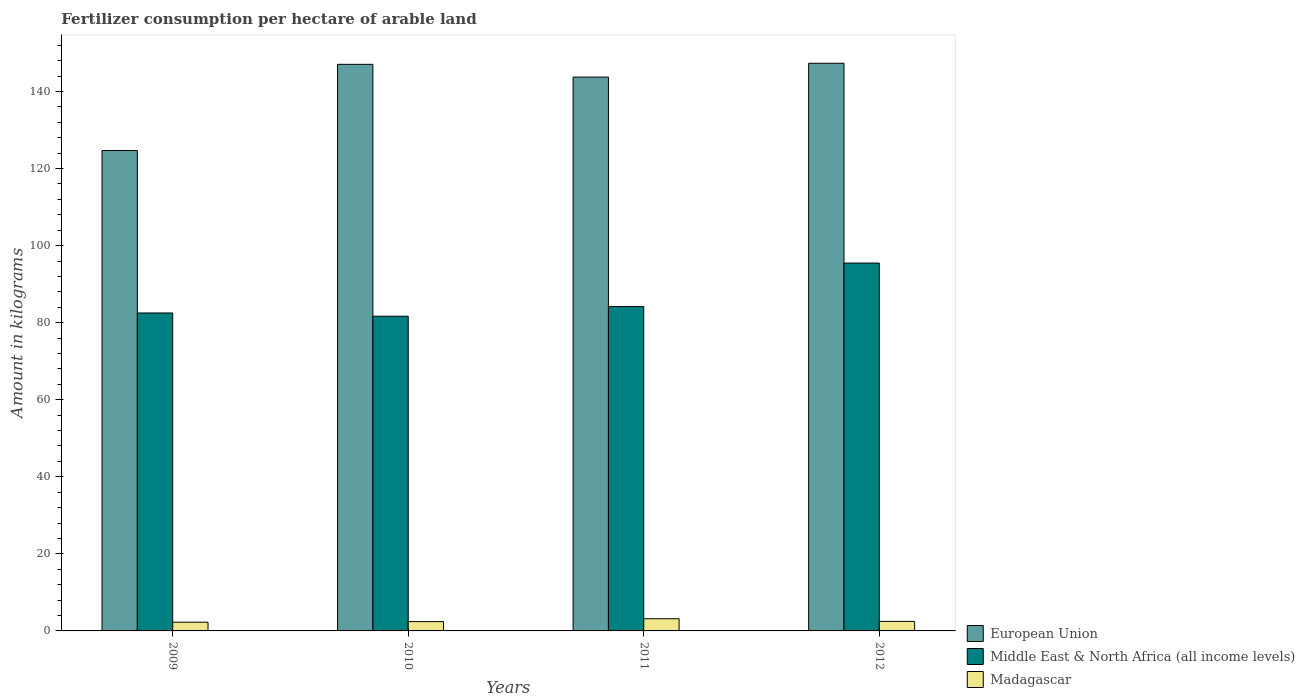Are the number of bars per tick equal to the number of legend labels?
Keep it short and to the point. Yes. Are the number of bars on each tick of the X-axis equal?
Give a very brief answer. Yes. How many bars are there on the 3rd tick from the right?
Provide a short and direct response. 3. What is the label of the 3rd group of bars from the left?
Offer a very short reply. 2011. What is the amount of fertilizer consumption in European Union in 2011?
Your answer should be compact. 143.75. Across all years, what is the maximum amount of fertilizer consumption in Middle East & North Africa (all income levels)?
Keep it short and to the point. 95.48. Across all years, what is the minimum amount of fertilizer consumption in Madagascar?
Your response must be concise. 2.27. What is the total amount of fertilizer consumption in European Union in the graph?
Make the answer very short. 562.84. What is the difference between the amount of fertilizer consumption in European Union in 2009 and that in 2011?
Provide a short and direct response. -19.07. What is the difference between the amount of fertilizer consumption in Madagascar in 2009 and the amount of fertilizer consumption in Middle East & North Africa (all income levels) in 2012?
Offer a very short reply. -93.21. What is the average amount of fertilizer consumption in Madagascar per year?
Your answer should be very brief. 2.58. In the year 2009, what is the difference between the amount of fertilizer consumption in European Union and amount of fertilizer consumption in Madagascar?
Keep it short and to the point. 122.42. What is the ratio of the amount of fertilizer consumption in Middle East & North Africa (all income levels) in 2009 to that in 2010?
Your answer should be very brief. 1.01. Is the amount of fertilizer consumption in Middle East & North Africa (all income levels) in 2009 less than that in 2011?
Provide a short and direct response. Yes. Is the difference between the amount of fertilizer consumption in European Union in 2009 and 2010 greater than the difference between the amount of fertilizer consumption in Madagascar in 2009 and 2010?
Offer a terse response. No. What is the difference between the highest and the second highest amount of fertilizer consumption in European Union?
Offer a terse response. 0.28. What is the difference between the highest and the lowest amount of fertilizer consumption in European Union?
Provide a succinct answer. 22.65. Is the sum of the amount of fertilizer consumption in European Union in 2009 and 2010 greater than the maximum amount of fertilizer consumption in Madagascar across all years?
Make the answer very short. Yes. What does the 3rd bar from the right in 2011 represents?
Keep it short and to the point. European Union. Is it the case that in every year, the sum of the amount of fertilizer consumption in Middle East & North Africa (all income levels) and amount of fertilizer consumption in Madagascar is greater than the amount of fertilizer consumption in European Union?
Offer a terse response. No. Are all the bars in the graph horizontal?
Ensure brevity in your answer.  No. How many years are there in the graph?
Provide a succinct answer. 4. Are the values on the major ticks of Y-axis written in scientific E-notation?
Keep it short and to the point. No. Does the graph contain grids?
Provide a short and direct response. No. Where does the legend appear in the graph?
Offer a very short reply. Bottom right. What is the title of the graph?
Offer a very short reply. Fertilizer consumption per hectare of arable land. Does "Bahamas" appear as one of the legend labels in the graph?
Give a very brief answer. No. What is the label or title of the Y-axis?
Your answer should be compact. Amount in kilograms. What is the Amount in kilograms of European Union in 2009?
Ensure brevity in your answer.  124.69. What is the Amount in kilograms of Middle East & North Africa (all income levels) in 2009?
Ensure brevity in your answer.  82.52. What is the Amount in kilograms of Madagascar in 2009?
Offer a very short reply. 2.27. What is the Amount in kilograms of European Union in 2010?
Your response must be concise. 147.06. What is the Amount in kilograms of Middle East & North Africa (all income levels) in 2010?
Offer a very short reply. 81.68. What is the Amount in kilograms in Madagascar in 2010?
Offer a very short reply. 2.42. What is the Amount in kilograms in European Union in 2011?
Provide a succinct answer. 143.75. What is the Amount in kilograms of Middle East & North Africa (all income levels) in 2011?
Keep it short and to the point. 84.18. What is the Amount in kilograms of Madagascar in 2011?
Keep it short and to the point. 3.16. What is the Amount in kilograms of European Union in 2012?
Your answer should be very brief. 147.34. What is the Amount in kilograms in Middle East & North Africa (all income levels) in 2012?
Provide a succinct answer. 95.48. What is the Amount in kilograms in Madagascar in 2012?
Make the answer very short. 2.48. Across all years, what is the maximum Amount in kilograms of European Union?
Offer a terse response. 147.34. Across all years, what is the maximum Amount in kilograms in Middle East & North Africa (all income levels)?
Your response must be concise. 95.48. Across all years, what is the maximum Amount in kilograms in Madagascar?
Offer a very short reply. 3.16. Across all years, what is the minimum Amount in kilograms in European Union?
Offer a terse response. 124.69. Across all years, what is the minimum Amount in kilograms of Middle East & North Africa (all income levels)?
Provide a short and direct response. 81.68. Across all years, what is the minimum Amount in kilograms of Madagascar?
Your answer should be very brief. 2.27. What is the total Amount in kilograms of European Union in the graph?
Make the answer very short. 562.84. What is the total Amount in kilograms in Middle East & North Africa (all income levels) in the graph?
Your answer should be very brief. 343.86. What is the total Amount in kilograms of Madagascar in the graph?
Ensure brevity in your answer.  10.32. What is the difference between the Amount in kilograms in European Union in 2009 and that in 2010?
Offer a very short reply. -22.37. What is the difference between the Amount in kilograms in Middle East & North Africa (all income levels) in 2009 and that in 2010?
Ensure brevity in your answer.  0.85. What is the difference between the Amount in kilograms of Madagascar in 2009 and that in 2010?
Keep it short and to the point. -0.15. What is the difference between the Amount in kilograms in European Union in 2009 and that in 2011?
Your response must be concise. -19.07. What is the difference between the Amount in kilograms of Middle East & North Africa (all income levels) in 2009 and that in 2011?
Provide a short and direct response. -1.66. What is the difference between the Amount in kilograms in Madagascar in 2009 and that in 2011?
Your answer should be very brief. -0.89. What is the difference between the Amount in kilograms in European Union in 2009 and that in 2012?
Give a very brief answer. -22.65. What is the difference between the Amount in kilograms in Middle East & North Africa (all income levels) in 2009 and that in 2012?
Offer a very short reply. -12.96. What is the difference between the Amount in kilograms of Madagascar in 2009 and that in 2012?
Provide a succinct answer. -0.21. What is the difference between the Amount in kilograms of European Union in 2010 and that in 2011?
Give a very brief answer. 3.31. What is the difference between the Amount in kilograms in Middle East & North Africa (all income levels) in 2010 and that in 2011?
Make the answer very short. -2.5. What is the difference between the Amount in kilograms in Madagascar in 2010 and that in 2011?
Your answer should be compact. -0.74. What is the difference between the Amount in kilograms in European Union in 2010 and that in 2012?
Your answer should be very brief. -0.28. What is the difference between the Amount in kilograms of Middle East & North Africa (all income levels) in 2010 and that in 2012?
Offer a very short reply. -13.8. What is the difference between the Amount in kilograms in Madagascar in 2010 and that in 2012?
Your response must be concise. -0.06. What is the difference between the Amount in kilograms of European Union in 2011 and that in 2012?
Your answer should be compact. -3.59. What is the difference between the Amount in kilograms of Middle East & North Africa (all income levels) in 2011 and that in 2012?
Ensure brevity in your answer.  -11.3. What is the difference between the Amount in kilograms of Madagascar in 2011 and that in 2012?
Your answer should be very brief. 0.68. What is the difference between the Amount in kilograms in European Union in 2009 and the Amount in kilograms in Middle East & North Africa (all income levels) in 2010?
Offer a very short reply. 43.01. What is the difference between the Amount in kilograms of European Union in 2009 and the Amount in kilograms of Madagascar in 2010?
Your response must be concise. 122.27. What is the difference between the Amount in kilograms of Middle East & North Africa (all income levels) in 2009 and the Amount in kilograms of Madagascar in 2010?
Provide a succinct answer. 80.11. What is the difference between the Amount in kilograms of European Union in 2009 and the Amount in kilograms of Middle East & North Africa (all income levels) in 2011?
Provide a short and direct response. 40.5. What is the difference between the Amount in kilograms of European Union in 2009 and the Amount in kilograms of Madagascar in 2011?
Keep it short and to the point. 121.53. What is the difference between the Amount in kilograms of Middle East & North Africa (all income levels) in 2009 and the Amount in kilograms of Madagascar in 2011?
Your answer should be compact. 79.36. What is the difference between the Amount in kilograms of European Union in 2009 and the Amount in kilograms of Middle East & North Africa (all income levels) in 2012?
Offer a very short reply. 29.21. What is the difference between the Amount in kilograms of European Union in 2009 and the Amount in kilograms of Madagascar in 2012?
Your answer should be very brief. 122.21. What is the difference between the Amount in kilograms in Middle East & North Africa (all income levels) in 2009 and the Amount in kilograms in Madagascar in 2012?
Keep it short and to the point. 80.05. What is the difference between the Amount in kilograms in European Union in 2010 and the Amount in kilograms in Middle East & North Africa (all income levels) in 2011?
Offer a terse response. 62.88. What is the difference between the Amount in kilograms in European Union in 2010 and the Amount in kilograms in Madagascar in 2011?
Provide a succinct answer. 143.9. What is the difference between the Amount in kilograms in Middle East & North Africa (all income levels) in 2010 and the Amount in kilograms in Madagascar in 2011?
Ensure brevity in your answer.  78.52. What is the difference between the Amount in kilograms of European Union in 2010 and the Amount in kilograms of Middle East & North Africa (all income levels) in 2012?
Give a very brief answer. 51.58. What is the difference between the Amount in kilograms of European Union in 2010 and the Amount in kilograms of Madagascar in 2012?
Your answer should be very brief. 144.58. What is the difference between the Amount in kilograms in Middle East & North Africa (all income levels) in 2010 and the Amount in kilograms in Madagascar in 2012?
Your answer should be very brief. 79.2. What is the difference between the Amount in kilograms of European Union in 2011 and the Amount in kilograms of Middle East & North Africa (all income levels) in 2012?
Your response must be concise. 48.27. What is the difference between the Amount in kilograms in European Union in 2011 and the Amount in kilograms in Madagascar in 2012?
Provide a succinct answer. 141.28. What is the difference between the Amount in kilograms of Middle East & North Africa (all income levels) in 2011 and the Amount in kilograms of Madagascar in 2012?
Give a very brief answer. 81.71. What is the average Amount in kilograms in European Union per year?
Provide a succinct answer. 140.71. What is the average Amount in kilograms in Middle East & North Africa (all income levels) per year?
Provide a short and direct response. 85.97. What is the average Amount in kilograms of Madagascar per year?
Your response must be concise. 2.58. In the year 2009, what is the difference between the Amount in kilograms of European Union and Amount in kilograms of Middle East & North Africa (all income levels)?
Your answer should be compact. 42.16. In the year 2009, what is the difference between the Amount in kilograms of European Union and Amount in kilograms of Madagascar?
Your response must be concise. 122.42. In the year 2009, what is the difference between the Amount in kilograms of Middle East & North Africa (all income levels) and Amount in kilograms of Madagascar?
Offer a terse response. 80.26. In the year 2010, what is the difference between the Amount in kilograms in European Union and Amount in kilograms in Middle East & North Africa (all income levels)?
Your response must be concise. 65.38. In the year 2010, what is the difference between the Amount in kilograms of European Union and Amount in kilograms of Madagascar?
Your answer should be very brief. 144.64. In the year 2010, what is the difference between the Amount in kilograms in Middle East & North Africa (all income levels) and Amount in kilograms in Madagascar?
Make the answer very short. 79.26. In the year 2011, what is the difference between the Amount in kilograms in European Union and Amount in kilograms in Middle East & North Africa (all income levels)?
Keep it short and to the point. 59.57. In the year 2011, what is the difference between the Amount in kilograms in European Union and Amount in kilograms in Madagascar?
Your answer should be very brief. 140.59. In the year 2011, what is the difference between the Amount in kilograms in Middle East & North Africa (all income levels) and Amount in kilograms in Madagascar?
Your answer should be compact. 81.02. In the year 2012, what is the difference between the Amount in kilograms of European Union and Amount in kilograms of Middle East & North Africa (all income levels)?
Your response must be concise. 51.86. In the year 2012, what is the difference between the Amount in kilograms of European Union and Amount in kilograms of Madagascar?
Keep it short and to the point. 144.86. In the year 2012, what is the difference between the Amount in kilograms in Middle East & North Africa (all income levels) and Amount in kilograms in Madagascar?
Make the answer very short. 93. What is the ratio of the Amount in kilograms in European Union in 2009 to that in 2010?
Your response must be concise. 0.85. What is the ratio of the Amount in kilograms of Middle East & North Africa (all income levels) in 2009 to that in 2010?
Your answer should be very brief. 1.01. What is the ratio of the Amount in kilograms in Madagascar in 2009 to that in 2010?
Your answer should be compact. 0.94. What is the ratio of the Amount in kilograms of European Union in 2009 to that in 2011?
Offer a terse response. 0.87. What is the ratio of the Amount in kilograms in Middle East & North Africa (all income levels) in 2009 to that in 2011?
Make the answer very short. 0.98. What is the ratio of the Amount in kilograms in Madagascar in 2009 to that in 2011?
Make the answer very short. 0.72. What is the ratio of the Amount in kilograms of European Union in 2009 to that in 2012?
Your answer should be very brief. 0.85. What is the ratio of the Amount in kilograms of Middle East & North Africa (all income levels) in 2009 to that in 2012?
Your answer should be compact. 0.86. What is the ratio of the Amount in kilograms in Madagascar in 2009 to that in 2012?
Give a very brief answer. 0.92. What is the ratio of the Amount in kilograms of European Union in 2010 to that in 2011?
Keep it short and to the point. 1.02. What is the ratio of the Amount in kilograms in Middle East & North Africa (all income levels) in 2010 to that in 2011?
Make the answer very short. 0.97. What is the ratio of the Amount in kilograms in Madagascar in 2010 to that in 2011?
Provide a succinct answer. 0.76. What is the ratio of the Amount in kilograms in Middle East & North Africa (all income levels) in 2010 to that in 2012?
Offer a very short reply. 0.86. What is the ratio of the Amount in kilograms of Madagascar in 2010 to that in 2012?
Offer a terse response. 0.98. What is the ratio of the Amount in kilograms of European Union in 2011 to that in 2012?
Your answer should be compact. 0.98. What is the ratio of the Amount in kilograms of Middle East & North Africa (all income levels) in 2011 to that in 2012?
Offer a very short reply. 0.88. What is the ratio of the Amount in kilograms of Madagascar in 2011 to that in 2012?
Offer a terse response. 1.28. What is the difference between the highest and the second highest Amount in kilograms of European Union?
Offer a very short reply. 0.28. What is the difference between the highest and the second highest Amount in kilograms of Middle East & North Africa (all income levels)?
Offer a very short reply. 11.3. What is the difference between the highest and the second highest Amount in kilograms in Madagascar?
Offer a very short reply. 0.68. What is the difference between the highest and the lowest Amount in kilograms in European Union?
Keep it short and to the point. 22.65. What is the difference between the highest and the lowest Amount in kilograms of Middle East & North Africa (all income levels)?
Keep it short and to the point. 13.8. What is the difference between the highest and the lowest Amount in kilograms in Madagascar?
Your answer should be very brief. 0.89. 